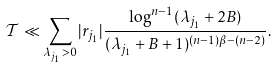<formula> <loc_0><loc_0><loc_500><loc_500>\mathcal { T } \ll \sum _ { \lambda _ { j _ { 1 } } > 0 } | r _ { j _ { 1 } } | \frac { \log ^ { n - 1 } ( \lambda _ { j _ { 1 } } + 2 B ) } { ( \lambda _ { j _ { 1 } } + B + 1 ) ^ { ( n - 1 ) \beta - ( n - 2 ) } } .</formula> 